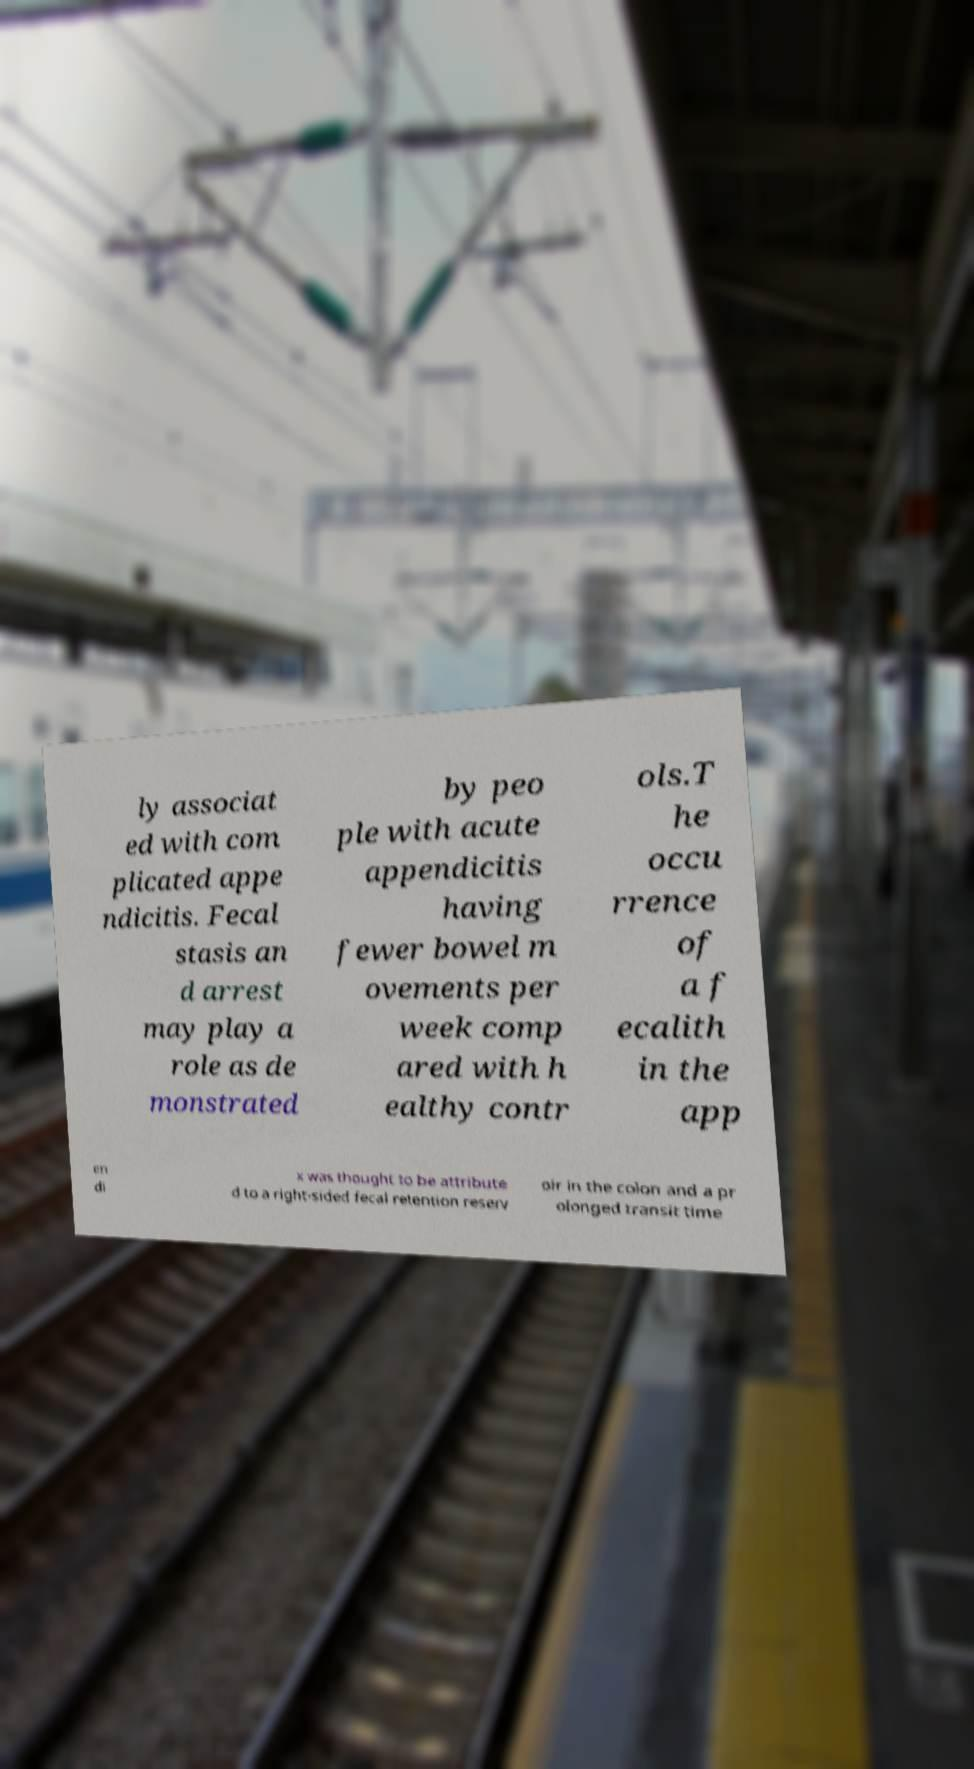Could you assist in decoding the text presented in this image and type it out clearly? ly associat ed with com plicated appe ndicitis. Fecal stasis an d arrest may play a role as de monstrated by peo ple with acute appendicitis having fewer bowel m ovements per week comp ared with h ealthy contr ols.T he occu rrence of a f ecalith in the app en di x was thought to be attribute d to a right-sided fecal retention reserv oir in the colon and a pr olonged transit time 